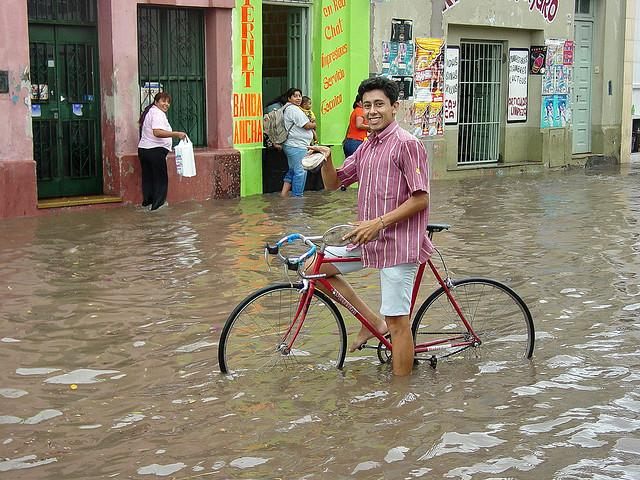Where is the man in? water 